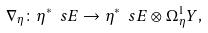<formula> <loc_0><loc_0><loc_500><loc_500>\nabla _ { \eta } \colon \eta ^ { \ast } \ s E \to \eta ^ { \ast } \ s E \otimes \Omega ^ { 1 } _ { \eta } Y ,</formula> 